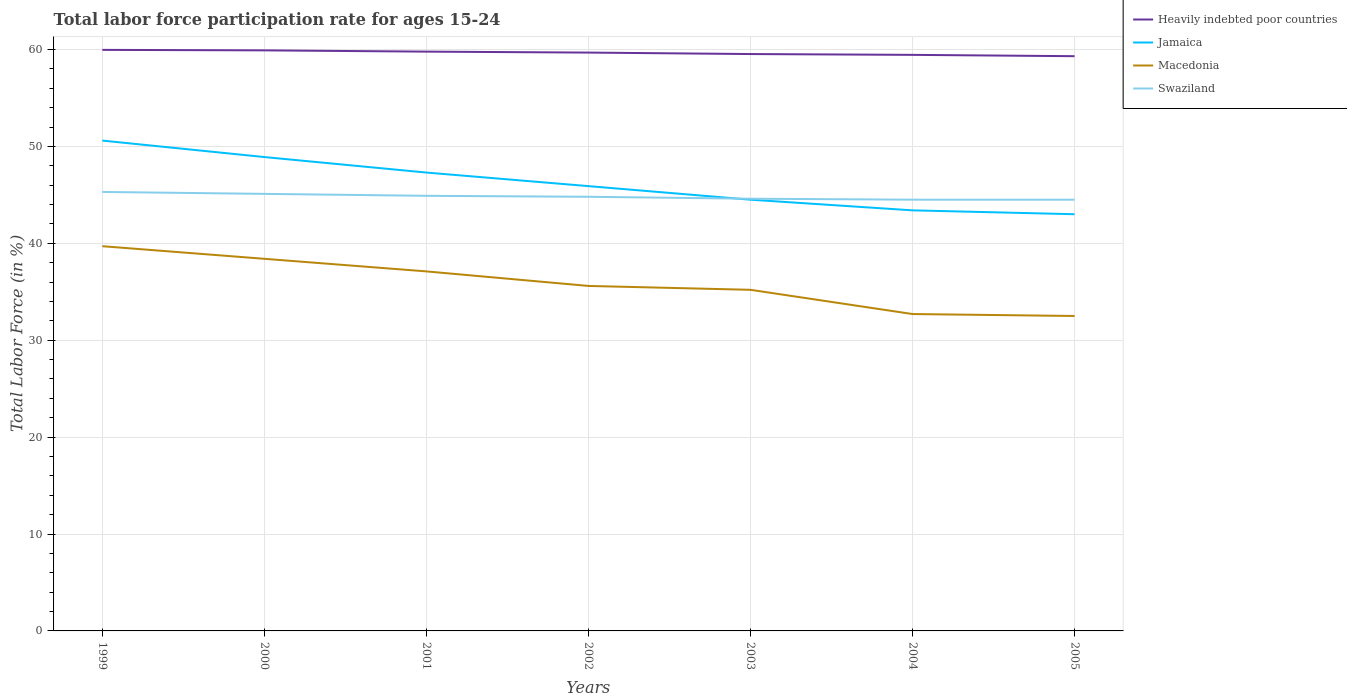How many different coloured lines are there?
Your answer should be compact. 4. Does the line corresponding to Heavily indebted poor countries intersect with the line corresponding to Swaziland?
Offer a terse response. No. Is the number of lines equal to the number of legend labels?
Ensure brevity in your answer.  Yes. Across all years, what is the maximum labor force participation rate in Macedonia?
Your answer should be compact. 32.5. In which year was the labor force participation rate in Heavily indebted poor countries maximum?
Your answer should be compact. 2005. What is the total labor force participation rate in Jamaica in the graph?
Ensure brevity in your answer.  3. What is the difference between the highest and the second highest labor force participation rate in Swaziland?
Your response must be concise. 0.8. What is the difference between the highest and the lowest labor force participation rate in Heavily indebted poor countries?
Provide a succinct answer. 4. Is the labor force participation rate in Macedonia strictly greater than the labor force participation rate in Swaziland over the years?
Offer a terse response. Yes. What is the difference between two consecutive major ticks on the Y-axis?
Your response must be concise. 10. Does the graph contain grids?
Provide a short and direct response. Yes. Where does the legend appear in the graph?
Your answer should be compact. Top right. How are the legend labels stacked?
Your answer should be very brief. Vertical. What is the title of the graph?
Provide a succinct answer. Total labor force participation rate for ages 15-24. What is the Total Labor Force (in %) of Heavily indebted poor countries in 1999?
Provide a succinct answer. 59.96. What is the Total Labor Force (in %) in Jamaica in 1999?
Your answer should be compact. 50.6. What is the Total Labor Force (in %) in Macedonia in 1999?
Make the answer very short. 39.7. What is the Total Labor Force (in %) in Swaziland in 1999?
Your answer should be very brief. 45.3. What is the Total Labor Force (in %) in Heavily indebted poor countries in 2000?
Offer a terse response. 59.91. What is the Total Labor Force (in %) in Jamaica in 2000?
Keep it short and to the point. 48.9. What is the Total Labor Force (in %) of Macedonia in 2000?
Ensure brevity in your answer.  38.4. What is the Total Labor Force (in %) of Swaziland in 2000?
Your answer should be compact. 45.1. What is the Total Labor Force (in %) in Heavily indebted poor countries in 2001?
Ensure brevity in your answer.  59.78. What is the Total Labor Force (in %) of Jamaica in 2001?
Your answer should be compact. 47.3. What is the Total Labor Force (in %) in Macedonia in 2001?
Offer a terse response. 37.1. What is the Total Labor Force (in %) of Swaziland in 2001?
Make the answer very short. 44.9. What is the Total Labor Force (in %) in Heavily indebted poor countries in 2002?
Provide a short and direct response. 59.68. What is the Total Labor Force (in %) of Jamaica in 2002?
Provide a succinct answer. 45.9. What is the Total Labor Force (in %) of Macedonia in 2002?
Offer a very short reply. 35.6. What is the Total Labor Force (in %) of Swaziland in 2002?
Give a very brief answer. 44.8. What is the Total Labor Force (in %) of Heavily indebted poor countries in 2003?
Offer a terse response. 59.53. What is the Total Labor Force (in %) of Jamaica in 2003?
Your answer should be compact. 44.5. What is the Total Labor Force (in %) in Macedonia in 2003?
Your answer should be compact. 35.2. What is the Total Labor Force (in %) of Swaziland in 2003?
Provide a succinct answer. 44.6. What is the Total Labor Force (in %) in Heavily indebted poor countries in 2004?
Provide a short and direct response. 59.45. What is the Total Labor Force (in %) in Jamaica in 2004?
Offer a very short reply. 43.4. What is the Total Labor Force (in %) in Macedonia in 2004?
Ensure brevity in your answer.  32.7. What is the Total Labor Force (in %) of Swaziland in 2004?
Offer a very short reply. 44.5. What is the Total Labor Force (in %) of Heavily indebted poor countries in 2005?
Provide a short and direct response. 59.31. What is the Total Labor Force (in %) in Jamaica in 2005?
Make the answer very short. 43. What is the Total Labor Force (in %) in Macedonia in 2005?
Ensure brevity in your answer.  32.5. What is the Total Labor Force (in %) in Swaziland in 2005?
Your answer should be very brief. 44.5. Across all years, what is the maximum Total Labor Force (in %) of Heavily indebted poor countries?
Your answer should be compact. 59.96. Across all years, what is the maximum Total Labor Force (in %) of Jamaica?
Provide a succinct answer. 50.6. Across all years, what is the maximum Total Labor Force (in %) in Macedonia?
Your answer should be compact. 39.7. Across all years, what is the maximum Total Labor Force (in %) of Swaziland?
Offer a very short reply. 45.3. Across all years, what is the minimum Total Labor Force (in %) in Heavily indebted poor countries?
Provide a short and direct response. 59.31. Across all years, what is the minimum Total Labor Force (in %) of Macedonia?
Your answer should be compact. 32.5. Across all years, what is the minimum Total Labor Force (in %) of Swaziland?
Make the answer very short. 44.5. What is the total Total Labor Force (in %) in Heavily indebted poor countries in the graph?
Provide a short and direct response. 417.61. What is the total Total Labor Force (in %) in Jamaica in the graph?
Give a very brief answer. 323.6. What is the total Total Labor Force (in %) of Macedonia in the graph?
Offer a very short reply. 251.2. What is the total Total Labor Force (in %) of Swaziland in the graph?
Your answer should be very brief. 313.7. What is the difference between the Total Labor Force (in %) of Heavily indebted poor countries in 1999 and that in 2000?
Your response must be concise. 0.05. What is the difference between the Total Labor Force (in %) in Jamaica in 1999 and that in 2000?
Give a very brief answer. 1.7. What is the difference between the Total Labor Force (in %) of Heavily indebted poor countries in 1999 and that in 2001?
Keep it short and to the point. 0.18. What is the difference between the Total Labor Force (in %) of Jamaica in 1999 and that in 2001?
Provide a short and direct response. 3.3. What is the difference between the Total Labor Force (in %) in Macedonia in 1999 and that in 2001?
Your answer should be very brief. 2.6. What is the difference between the Total Labor Force (in %) in Swaziland in 1999 and that in 2001?
Make the answer very short. 0.4. What is the difference between the Total Labor Force (in %) of Heavily indebted poor countries in 1999 and that in 2002?
Keep it short and to the point. 0.28. What is the difference between the Total Labor Force (in %) in Swaziland in 1999 and that in 2002?
Offer a very short reply. 0.5. What is the difference between the Total Labor Force (in %) of Heavily indebted poor countries in 1999 and that in 2003?
Provide a short and direct response. 0.43. What is the difference between the Total Labor Force (in %) of Jamaica in 1999 and that in 2003?
Provide a short and direct response. 6.1. What is the difference between the Total Labor Force (in %) in Heavily indebted poor countries in 1999 and that in 2004?
Provide a short and direct response. 0.51. What is the difference between the Total Labor Force (in %) in Jamaica in 1999 and that in 2004?
Keep it short and to the point. 7.2. What is the difference between the Total Labor Force (in %) of Heavily indebted poor countries in 1999 and that in 2005?
Provide a short and direct response. 0.65. What is the difference between the Total Labor Force (in %) of Macedonia in 1999 and that in 2005?
Give a very brief answer. 7.2. What is the difference between the Total Labor Force (in %) in Swaziland in 1999 and that in 2005?
Keep it short and to the point. 0.8. What is the difference between the Total Labor Force (in %) in Heavily indebted poor countries in 2000 and that in 2001?
Offer a very short reply. 0.13. What is the difference between the Total Labor Force (in %) in Jamaica in 2000 and that in 2001?
Your answer should be very brief. 1.6. What is the difference between the Total Labor Force (in %) in Macedonia in 2000 and that in 2001?
Give a very brief answer. 1.3. What is the difference between the Total Labor Force (in %) in Swaziland in 2000 and that in 2001?
Your response must be concise. 0.2. What is the difference between the Total Labor Force (in %) in Heavily indebted poor countries in 2000 and that in 2002?
Your answer should be very brief. 0.23. What is the difference between the Total Labor Force (in %) of Heavily indebted poor countries in 2000 and that in 2003?
Keep it short and to the point. 0.38. What is the difference between the Total Labor Force (in %) in Jamaica in 2000 and that in 2003?
Your response must be concise. 4.4. What is the difference between the Total Labor Force (in %) in Macedonia in 2000 and that in 2003?
Provide a short and direct response. 3.2. What is the difference between the Total Labor Force (in %) of Heavily indebted poor countries in 2000 and that in 2004?
Your answer should be very brief. 0.46. What is the difference between the Total Labor Force (in %) of Jamaica in 2000 and that in 2004?
Give a very brief answer. 5.5. What is the difference between the Total Labor Force (in %) in Heavily indebted poor countries in 2000 and that in 2005?
Make the answer very short. 0.6. What is the difference between the Total Labor Force (in %) in Jamaica in 2000 and that in 2005?
Ensure brevity in your answer.  5.9. What is the difference between the Total Labor Force (in %) of Macedonia in 2000 and that in 2005?
Your answer should be compact. 5.9. What is the difference between the Total Labor Force (in %) in Swaziland in 2000 and that in 2005?
Ensure brevity in your answer.  0.6. What is the difference between the Total Labor Force (in %) of Heavily indebted poor countries in 2001 and that in 2002?
Keep it short and to the point. 0.1. What is the difference between the Total Labor Force (in %) in Jamaica in 2001 and that in 2002?
Your answer should be compact. 1.4. What is the difference between the Total Labor Force (in %) in Swaziland in 2001 and that in 2002?
Make the answer very short. 0.1. What is the difference between the Total Labor Force (in %) in Heavily indebted poor countries in 2001 and that in 2003?
Ensure brevity in your answer.  0.25. What is the difference between the Total Labor Force (in %) of Macedonia in 2001 and that in 2003?
Provide a short and direct response. 1.9. What is the difference between the Total Labor Force (in %) in Heavily indebted poor countries in 2001 and that in 2004?
Your response must be concise. 0.33. What is the difference between the Total Labor Force (in %) in Jamaica in 2001 and that in 2004?
Give a very brief answer. 3.9. What is the difference between the Total Labor Force (in %) of Heavily indebted poor countries in 2001 and that in 2005?
Ensure brevity in your answer.  0.47. What is the difference between the Total Labor Force (in %) of Swaziland in 2001 and that in 2005?
Your response must be concise. 0.4. What is the difference between the Total Labor Force (in %) in Heavily indebted poor countries in 2002 and that in 2003?
Your answer should be very brief. 0.15. What is the difference between the Total Labor Force (in %) of Macedonia in 2002 and that in 2003?
Your answer should be very brief. 0.4. What is the difference between the Total Labor Force (in %) in Heavily indebted poor countries in 2002 and that in 2004?
Provide a succinct answer. 0.23. What is the difference between the Total Labor Force (in %) of Jamaica in 2002 and that in 2004?
Provide a short and direct response. 2.5. What is the difference between the Total Labor Force (in %) in Macedonia in 2002 and that in 2004?
Make the answer very short. 2.9. What is the difference between the Total Labor Force (in %) in Swaziland in 2002 and that in 2004?
Ensure brevity in your answer.  0.3. What is the difference between the Total Labor Force (in %) of Heavily indebted poor countries in 2002 and that in 2005?
Offer a very short reply. 0.37. What is the difference between the Total Labor Force (in %) in Jamaica in 2002 and that in 2005?
Offer a terse response. 2.9. What is the difference between the Total Labor Force (in %) of Heavily indebted poor countries in 2003 and that in 2004?
Provide a short and direct response. 0.08. What is the difference between the Total Labor Force (in %) in Jamaica in 2003 and that in 2004?
Ensure brevity in your answer.  1.1. What is the difference between the Total Labor Force (in %) of Swaziland in 2003 and that in 2004?
Keep it short and to the point. 0.1. What is the difference between the Total Labor Force (in %) of Heavily indebted poor countries in 2003 and that in 2005?
Ensure brevity in your answer.  0.22. What is the difference between the Total Labor Force (in %) in Jamaica in 2003 and that in 2005?
Your answer should be very brief. 1.5. What is the difference between the Total Labor Force (in %) of Swaziland in 2003 and that in 2005?
Offer a terse response. 0.1. What is the difference between the Total Labor Force (in %) in Heavily indebted poor countries in 2004 and that in 2005?
Your answer should be compact. 0.14. What is the difference between the Total Labor Force (in %) in Heavily indebted poor countries in 1999 and the Total Labor Force (in %) in Jamaica in 2000?
Your response must be concise. 11.06. What is the difference between the Total Labor Force (in %) in Heavily indebted poor countries in 1999 and the Total Labor Force (in %) in Macedonia in 2000?
Offer a very short reply. 21.56. What is the difference between the Total Labor Force (in %) in Heavily indebted poor countries in 1999 and the Total Labor Force (in %) in Swaziland in 2000?
Make the answer very short. 14.86. What is the difference between the Total Labor Force (in %) in Macedonia in 1999 and the Total Labor Force (in %) in Swaziland in 2000?
Provide a short and direct response. -5.4. What is the difference between the Total Labor Force (in %) in Heavily indebted poor countries in 1999 and the Total Labor Force (in %) in Jamaica in 2001?
Offer a very short reply. 12.66. What is the difference between the Total Labor Force (in %) of Heavily indebted poor countries in 1999 and the Total Labor Force (in %) of Macedonia in 2001?
Give a very brief answer. 22.86. What is the difference between the Total Labor Force (in %) of Heavily indebted poor countries in 1999 and the Total Labor Force (in %) of Swaziland in 2001?
Offer a very short reply. 15.06. What is the difference between the Total Labor Force (in %) in Jamaica in 1999 and the Total Labor Force (in %) in Macedonia in 2001?
Provide a succinct answer. 13.5. What is the difference between the Total Labor Force (in %) of Macedonia in 1999 and the Total Labor Force (in %) of Swaziland in 2001?
Provide a short and direct response. -5.2. What is the difference between the Total Labor Force (in %) in Heavily indebted poor countries in 1999 and the Total Labor Force (in %) in Jamaica in 2002?
Ensure brevity in your answer.  14.06. What is the difference between the Total Labor Force (in %) in Heavily indebted poor countries in 1999 and the Total Labor Force (in %) in Macedonia in 2002?
Keep it short and to the point. 24.36. What is the difference between the Total Labor Force (in %) in Heavily indebted poor countries in 1999 and the Total Labor Force (in %) in Swaziland in 2002?
Your answer should be compact. 15.16. What is the difference between the Total Labor Force (in %) of Jamaica in 1999 and the Total Labor Force (in %) of Macedonia in 2002?
Your answer should be compact. 15. What is the difference between the Total Labor Force (in %) of Jamaica in 1999 and the Total Labor Force (in %) of Swaziland in 2002?
Provide a short and direct response. 5.8. What is the difference between the Total Labor Force (in %) of Macedonia in 1999 and the Total Labor Force (in %) of Swaziland in 2002?
Keep it short and to the point. -5.1. What is the difference between the Total Labor Force (in %) in Heavily indebted poor countries in 1999 and the Total Labor Force (in %) in Jamaica in 2003?
Offer a very short reply. 15.46. What is the difference between the Total Labor Force (in %) of Heavily indebted poor countries in 1999 and the Total Labor Force (in %) of Macedonia in 2003?
Offer a very short reply. 24.76. What is the difference between the Total Labor Force (in %) of Heavily indebted poor countries in 1999 and the Total Labor Force (in %) of Swaziland in 2003?
Give a very brief answer. 15.36. What is the difference between the Total Labor Force (in %) of Jamaica in 1999 and the Total Labor Force (in %) of Macedonia in 2003?
Your answer should be very brief. 15.4. What is the difference between the Total Labor Force (in %) in Macedonia in 1999 and the Total Labor Force (in %) in Swaziland in 2003?
Your answer should be very brief. -4.9. What is the difference between the Total Labor Force (in %) in Heavily indebted poor countries in 1999 and the Total Labor Force (in %) in Jamaica in 2004?
Keep it short and to the point. 16.56. What is the difference between the Total Labor Force (in %) of Heavily indebted poor countries in 1999 and the Total Labor Force (in %) of Macedonia in 2004?
Your answer should be compact. 27.26. What is the difference between the Total Labor Force (in %) in Heavily indebted poor countries in 1999 and the Total Labor Force (in %) in Swaziland in 2004?
Offer a very short reply. 15.46. What is the difference between the Total Labor Force (in %) of Jamaica in 1999 and the Total Labor Force (in %) of Macedonia in 2004?
Offer a very short reply. 17.9. What is the difference between the Total Labor Force (in %) in Macedonia in 1999 and the Total Labor Force (in %) in Swaziland in 2004?
Your answer should be compact. -4.8. What is the difference between the Total Labor Force (in %) of Heavily indebted poor countries in 1999 and the Total Labor Force (in %) of Jamaica in 2005?
Keep it short and to the point. 16.96. What is the difference between the Total Labor Force (in %) of Heavily indebted poor countries in 1999 and the Total Labor Force (in %) of Macedonia in 2005?
Make the answer very short. 27.46. What is the difference between the Total Labor Force (in %) in Heavily indebted poor countries in 1999 and the Total Labor Force (in %) in Swaziland in 2005?
Keep it short and to the point. 15.46. What is the difference between the Total Labor Force (in %) of Jamaica in 1999 and the Total Labor Force (in %) of Macedonia in 2005?
Ensure brevity in your answer.  18.1. What is the difference between the Total Labor Force (in %) in Jamaica in 1999 and the Total Labor Force (in %) in Swaziland in 2005?
Keep it short and to the point. 6.1. What is the difference between the Total Labor Force (in %) in Heavily indebted poor countries in 2000 and the Total Labor Force (in %) in Jamaica in 2001?
Your answer should be compact. 12.61. What is the difference between the Total Labor Force (in %) in Heavily indebted poor countries in 2000 and the Total Labor Force (in %) in Macedonia in 2001?
Provide a short and direct response. 22.81. What is the difference between the Total Labor Force (in %) in Heavily indebted poor countries in 2000 and the Total Labor Force (in %) in Swaziland in 2001?
Give a very brief answer. 15.01. What is the difference between the Total Labor Force (in %) in Jamaica in 2000 and the Total Labor Force (in %) in Macedonia in 2001?
Provide a short and direct response. 11.8. What is the difference between the Total Labor Force (in %) of Macedonia in 2000 and the Total Labor Force (in %) of Swaziland in 2001?
Ensure brevity in your answer.  -6.5. What is the difference between the Total Labor Force (in %) of Heavily indebted poor countries in 2000 and the Total Labor Force (in %) of Jamaica in 2002?
Provide a short and direct response. 14.01. What is the difference between the Total Labor Force (in %) of Heavily indebted poor countries in 2000 and the Total Labor Force (in %) of Macedonia in 2002?
Offer a very short reply. 24.31. What is the difference between the Total Labor Force (in %) of Heavily indebted poor countries in 2000 and the Total Labor Force (in %) of Swaziland in 2002?
Your answer should be compact. 15.11. What is the difference between the Total Labor Force (in %) of Jamaica in 2000 and the Total Labor Force (in %) of Swaziland in 2002?
Offer a terse response. 4.1. What is the difference between the Total Labor Force (in %) in Macedonia in 2000 and the Total Labor Force (in %) in Swaziland in 2002?
Ensure brevity in your answer.  -6.4. What is the difference between the Total Labor Force (in %) of Heavily indebted poor countries in 2000 and the Total Labor Force (in %) of Jamaica in 2003?
Your answer should be very brief. 15.41. What is the difference between the Total Labor Force (in %) in Heavily indebted poor countries in 2000 and the Total Labor Force (in %) in Macedonia in 2003?
Make the answer very short. 24.71. What is the difference between the Total Labor Force (in %) in Heavily indebted poor countries in 2000 and the Total Labor Force (in %) in Swaziland in 2003?
Your answer should be compact. 15.31. What is the difference between the Total Labor Force (in %) in Jamaica in 2000 and the Total Labor Force (in %) in Swaziland in 2003?
Ensure brevity in your answer.  4.3. What is the difference between the Total Labor Force (in %) of Macedonia in 2000 and the Total Labor Force (in %) of Swaziland in 2003?
Your answer should be very brief. -6.2. What is the difference between the Total Labor Force (in %) of Heavily indebted poor countries in 2000 and the Total Labor Force (in %) of Jamaica in 2004?
Make the answer very short. 16.51. What is the difference between the Total Labor Force (in %) in Heavily indebted poor countries in 2000 and the Total Labor Force (in %) in Macedonia in 2004?
Give a very brief answer. 27.21. What is the difference between the Total Labor Force (in %) in Heavily indebted poor countries in 2000 and the Total Labor Force (in %) in Swaziland in 2004?
Offer a terse response. 15.41. What is the difference between the Total Labor Force (in %) in Jamaica in 2000 and the Total Labor Force (in %) in Swaziland in 2004?
Ensure brevity in your answer.  4.4. What is the difference between the Total Labor Force (in %) in Macedonia in 2000 and the Total Labor Force (in %) in Swaziland in 2004?
Keep it short and to the point. -6.1. What is the difference between the Total Labor Force (in %) of Heavily indebted poor countries in 2000 and the Total Labor Force (in %) of Jamaica in 2005?
Offer a very short reply. 16.91. What is the difference between the Total Labor Force (in %) in Heavily indebted poor countries in 2000 and the Total Labor Force (in %) in Macedonia in 2005?
Your answer should be compact. 27.41. What is the difference between the Total Labor Force (in %) of Heavily indebted poor countries in 2000 and the Total Labor Force (in %) of Swaziland in 2005?
Provide a succinct answer. 15.41. What is the difference between the Total Labor Force (in %) of Jamaica in 2000 and the Total Labor Force (in %) of Swaziland in 2005?
Make the answer very short. 4.4. What is the difference between the Total Labor Force (in %) of Heavily indebted poor countries in 2001 and the Total Labor Force (in %) of Jamaica in 2002?
Give a very brief answer. 13.88. What is the difference between the Total Labor Force (in %) in Heavily indebted poor countries in 2001 and the Total Labor Force (in %) in Macedonia in 2002?
Give a very brief answer. 24.18. What is the difference between the Total Labor Force (in %) of Heavily indebted poor countries in 2001 and the Total Labor Force (in %) of Swaziland in 2002?
Provide a succinct answer. 14.98. What is the difference between the Total Labor Force (in %) in Jamaica in 2001 and the Total Labor Force (in %) in Macedonia in 2002?
Your answer should be very brief. 11.7. What is the difference between the Total Labor Force (in %) in Macedonia in 2001 and the Total Labor Force (in %) in Swaziland in 2002?
Offer a terse response. -7.7. What is the difference between the Total Labor Force (in %) of Heavily indebted poor countries in 2001 and the Total Labor Force (in %) of Jamaica in 2003?
Provide a short and direct response. 15.28. What is the difference between the Total Labor Force (in %) of Heavily indebted poor countries in 2001 and the Total Labor Force (in %) of Macedonia in 2003?
Ensure brevity in your answer.  24.58. What is the difference between the Total Labor Force (in %) of Heavily indebted poor countries in 2001 and the Total Labor Force (in %) of Swaziland in 2003?
Ensure brevity in your answer.  15.18. What is the difference between the Total Labor Force (in %) in Heavily indebted poor countries in 2001 and the Total Labor Force (in %) in Jamaica in 2004?
Offer a terse response. 16.38. What is the difference between the Total Labor Force (in %) in Heavily indebted poor countries in 2001 and the Total Labor Force (in %) in Macedonia in 2004?
Make the answer very short. 27.08. What is the difference between the Total Labor Force (in %) in Heavily indebted poor countries in 2001 and the Total Labor Force (in %) in Swaziland in 2004?
Your answer should be very brief. 15.28. What is the difference between the Total Labor Force (in %) of Jamaica in 2001 and the Total Labor Force (in %) of Swaziland in 2004?
Your answer should be very brief. 2.8. What is the difference between the Total Labor Force (in %) of Macedonia in 2001 and the Total Labor Force (in %) of Swaziland in 2004?
Offer a very short reply. -7.4. What is the difference between the Total Labor Force (in %) of Heavily indebted poor countries in 2001 and the Total Labor Force (in %) of Jamaica in 2005?
Ensure brevity in your answer.  16.78. What is the difference between the Total Labor Force (in %) in Heavily indebted poor countries in 2001 and the Total Labor Force (in %) in Macedonia in 2005?
Keep it short and to the point. 27.28. What is the difference between the Total Labor Force (in %) in Heavily indebted poor countries in 2001 and the Total Labor Force (in %) in Swaziland in 2005?
Make the answer very short. 15.28. What is the difference between the Total Labor Force (in %) in Macedonia in 2001 and the Total Labor Force (in %) in Swaziland in 2005?
Make the answer very short. -7.4. What is the difference between the Total Labor Force (in %) in Heavily indebted poor countries in 2002 and the Total Labor Force (in %) in Jamaica in 2003?
Your answer should be compact. 15.18. What is the difference between the Total Labor Force (in %) of Heavily indebted poor countries in 2002 and the Total Labor Force (in %) of Macedonia in 2003?
Offer a very short reply. 24.48. What is the difference between the Total Labor Force (in %) in Heavily indebted poor countries in 2002 and the Total Labor Force (in %) in Swaziland in 2003?
Ensure brevity in your answer.  15.08. What is the difference between the Total Labor Force (in %) of Heavily indebted poor countries in 2002 and the Total Labor Force (in %) of Jamaica in 2004?
Offer a very short reply. 16.28. What is the difference between the Total Labor Force (in %) in Heavily indebted poor countries in 2002 and the Total Labor Force (in %) in Macedonia in 2004?
Your answer should be compact. 26.98. What is the difference between the Total Labor Force (in %) of Heavily indebted poor countries in 2002 and the Total Labor Force (in %) of Swaziland in 2004?
Your answer should be very brief. 15.18. What is the difference between the Total Labor Force (in %) of Jamaica in 2002 and the Total Labor Force (in %) of Swaziland in 2004?
Your answer should be compact. 1.4. What is the difference between the Total Labor Force (in %) in Macedonia in 2002 and the Total Labor Force (in %) in Swaziland in 2004?
Give a very brief answer. -8.9. What is the difference between the Total Labor Force (in %) of Heavily indebted poor countries in 2002 and the Total Labor Force (in %) of Jamaica in 2005?
Give a very brief answer. 16.68. What is the difference between the Total Labor Force (in %) of Heavily indebted poor countries in 2002 and the Total Labor Force (in %) of Macedonia in 2005?
Keep it short and to the point. 27.18. What is the difference between the Total Labor Force (in %) in Heavily indebted poor countries in 2002 and the Total Labor Force (in %) in Swaziland in 2005?
Make the answer very short. 15.18. What is the difference between the Total Labor Force (in %) of Jamaica in 2002 and the Total Labor Force (in %) of Macedonia in 2005?
Ensure brevity in your answer.  13.4. What is the difference between the Total Labor Force (in %) in Jamaica in 2002 and the Total Labor Force (in %) in Swaziland in 2005?
Your response must be concise. 1.4. What is the difference between the Total Labor Force (in %) of Heavily indebted poor countries in 2003 and the Total Labor Force (in %) of Jamaica in 2004?
Give a very brief answer. 16.13. What is the difference between the Total Labor Force (in %) in Heavily indebted poor countries in 2003 and the Total Labor Force (in %) in Macedonia in 2004?
Provide a succinct answer. 26.83. What is the difference between the Total Labor Force (in %) in Heavily indebted poor countries in 2003 and the Total Labor Force (in %) in Swaziland in 2004?
Offer a very short reply. 15.03. What is the difference between the Total Labor Force (in %) of Jamaica in 2003 and the Total Labor Force (in %) of Macedonia in 2004?
Your answer should be very brief. 11.8. What is the difference between the Total Labor Force (in %) of Heavily indebted poor countries in 2003 and the Total Labor Force (in %) of Jamaica in 2005?
Provide a short and direct response. 16.53. What is the difference between the Total Labor Force (in %) of Heavily indebted poor countries in 2003 and the Total Labor Force (in %) of Macedonia in 2005?
Provide a short and direct response. 27.03. What is the difference between the Total Labor Force (in %) in Heavily indebted poor countries in 2003 and the Total Labor Force (in %) in Swaziland in 2005?
Your response must be concise. 15.03. What is the difference between the Total Labor Force (in %) in Jamaica in 2003 and the Total Labor Force (in %) in Macedonia in 2005?
Provide a succinct answer. 12. What is the difference between the Total Labor Force (in %) of Jamaica in 2003 and the Total Labor Force (in %) of Swaziland in 2005?
Give a very brief answer. 0. What is the difference between the Total Labor Force (in %) in Heavily indebted poor countries in 2004 and the Total Labor Force (in %) in Jamaica in 2005?
Keep it short and to the point. 16.45. What is the difference between the Total Labor Force (in %) of Heavily indebted poor countries in 2004 and the Total Labor Force (in %) of Macedonia in 2005?
Keep it short and to the point. 26.95. What is the difference between the Total Labor Force (in %) of Heavily indebted poor countries in 2004 and the Total Labor Force (in %) of Swaziland in 2005?
Provide a short and direct response. 14.95. What is the difference between the Total Labor Force (in %) of Jamaica in 2004 and the Total Labor Force (in %) of Swaziland in 2005?
Your response must be concise. -1.1. What is the difference between the Total Labor Force (in %) of Macedonia in 2004 and the Total Labor Force (in %) of Swaziland in 2005?
Keep it short and to the point. -11.8. What is the average Total Labor Force (in %) of Heavily indebted poor countries per year?
Offer a very short reply. 59.66. What is the average Total Labor Force (in %) of Jamaica per year?
Keep it short and to the point. 46.23. What is the average Total Labor Force (in %) of Macedonia per year?
Keep it short and to the point. 35.89. What is the average Total Labor Force (in %) of Swaziland per year?
Provide a succinct answer. 44.81. In the year 1999, what is the difference between the Total Labor Force (in %) in Heavily indebted poor countries and Total Labor Force (in %) in Jamaica?
Give a very brief answer. 9.36. In the year 1999, what is the difference between the Total Labor Force (in %) of Heavily indebted poor countries and Total Labor Force (in %) of Macedonia?
Keep it short and to the point. 20.26. In the year 1999, what is the difference between the Total Labor Force (in %) in Heavily indebted poor countries and Total Labor Force (in %) in Swaziland?
Offer a terse response. 14.66. In the year 1999, what is the difference between the Total Labor Force (in %) in Jamaica and Total Labor Force (in %) in Macedonia?
Keep it short and to the point. 10.9. In the year 2000, what is the difference between the Total Labor Force (in %) of Heavily indebted poor countries and Total Labor Force (in %) of Jamaica?
Give a very brief answer. 11.01. In the year 2000, what is the difference between the Total Labor Force (in %) in Heavily indebted poor countries and Total Labor Force (in %) in Macedonia?
Keep it short and to the point. 21.51. In the year 2000, what is the difference between the Total Labor Force (in %) in Heavily indebted poor countries and Total Labor Force (in %) in Swaziland?
Offer a very short reply. 14.81. In the year 2000, what is the difference between the Total Labor Force (in %) of Jamaica and Total Labor Force (in %) of Macedonia?
Your response must be concise. 10.5. In the year 2000, what is the difference between the Total Labor Force (in %) of Macedonia and Total Labor Force (in %) of Swaziland?
Ensure brevity in your answer.  -6.7. In the year 2001, what is the difference between the Total Labor Force (in %) of Heavily indebted poor countries and Total Labor Force (in %) of Jamaica?
Your answer should be compact. 12.48. In the year 2001, what is the difference between the Total Labor Force (in %) in Heavily indebted poor countries and Total Labor Force (in %) in Macedonia?
Offer a terse response. 22.68. In the year 2001, what is the difference between the Total Labor Force (in %) in Heavily indebted poor countries and Total Labor Force (in %) in Swaziland?
Give a very brief answer. 14.88. In the year 2001, what is the difference between the Total Labor Force (in %) in Jamaica and Total Labor Force (in %) in Swaziland?
Your answer should be compact. 2.4. In the year 2001, what is the difference between the Total Labor Force (in %) of Macedonia and Total Labor Force (in %) of Swaziland?
Offer a very short reply. -7.8. In the year 2002, what is the difference between the Total Labor Force (in %) of Heavily indebted poor countries and Total Labor Force (in %) of Jamaica?
Provide a succinct answer. 13.78. In the year 2002, what is the difference between the Total Labor Force (in %) in Heavily indebted poor countries and Total Labor Force (in %) in Macedonia?
Your response must be concise. 24.08. In the year 2002, what is the difference between the Total Labor Force (in %) of Heavily indebted poor countries and Total Labor Force (in %) of Swaziland?
Offer a very short reply. 14.88. In the year 2002, what is the difference between the Total Labor Force (in %) in Jamaica and Total Labor Force (in %) in Macedonia?
Your answer should be very brief. 10.3. In the year 2002, what is the difference between the Total Labor Force (in %) in Jamaica and Total Labor Force (in %) in Swaziland?
Your response must be concise. 1.1. In the year 2002, what is the difference between the Total Labor Force (in %) in Macedonia and Total Labor Force (in %) in Swaziland?
Provide a succinct answer. -9.2. In the year 2003, what is the difference between the Total Labor Force (in %) of Heavily indebted poor countries and Total Labor Force (in %) of Jamaica?
Your answer should be very brief. 15.03. In the year 2003, what is the difference between the Total Labor Force (in %) in Heavily indebted poor countries and Total Labor Force (in %) in Macedonia?
Make the answer very short. 24.33. In the year 2003, what is the difference between the Total Labor Force (in %) of Heavily indebted poor countries and Total Labor Force (in %) of Swaziland?
Provide a succinct answer. 14.93. In the year 2003, what is the difference between the Total Labor Force (in %) in Jamaica and Total Labor Force (in %) in Swaziland?
Offer a very short reply. -0.1. In the year 2003, what is the difference between the Total Labor Force (in %) of Macedonia and Total Labor Force (in %) of Swaziland?
Keep it short and to the point. -9.4. In the year 2004, what is the difference between the Total Labor Force (in %) in Heavily indebted poor countries and Total Labor Force (in %) in Jamaica?
Keep it short and to the point. 16.05. In the year 2004, what is the difference between the Total Labor Force (in %) in Heavily indebted poor countries and Total Labor Force (in %) in Macedonia?
Your answer should be very brief. 26.75. In the year 2004, what is the difference between the Total Labor Force (in %) of Heavily indebted poor countries and Total Labor Force (in %) of Swaziland?
Provide a succinct answer. 14.95. In the year 2004, what is the difference between the Total Labor Force (in %) in Jamaica and Total Labor Force (in %) in Macedonia?
Ensure brevity in your answer.  10.7. In the year 2005, what is the difference between the Total Labor Force (in %) in Heavily indebted poor countries and Total Labor Force (in %) in Jamaica?
Make the answer very short. 16.31. In the year 2005, what is the difference between the Total Labor Force (in %) of Heavily indebted poor countries and Total Labor Force (in %) of Macedonia?
Your answer should be very brief. 26.81. In the year 2005, what is the difference between the Total Labor Force (in %) in Heavily indebted poor countries and Total Labor Force (in %) in Swaziland?
Provide a succinct answer. 14.81. What is the ratio of the Total Labor Force (in %) in Jamaica in 1999 to that in 2000?
Your answer should be very brief. 1.03. What is the ratio of the Total Labor Force (in %) of Macedonia in 1999 to that in 2000?
Offer a terse response. 1.03. What is the ratio of the Total Labor Force (in %) in Swaziland in 1999 to that in 2000?
Offer a terse response. 1. What is the ratio of the Total Labor Force (in %) in Jamaica in 1999 to that in 2001?
Offer a terse response. 1.07. What is the ratio of the Total Labor Force (in %) of Macedonia in 1999 to that in 2001?
Provide a succinct answer. 1.07. What is the ratio of the Total Labor Force (in %) of Swaziland in 1999 to that in 2001?
Ensure brevity in your answer.  1.01. What is the ratio of the Total Labor Force (in %) in Jamaica in 1999 to that in 2002?
Your response must be concise. 1.1. What is the ratio of the Total Labor Force (in %) in Macedonia in 1999 to that in 2002?
Provide a short and direct response. 1.12. What is the ratio of the Total Labor Force (in %) of Swaziland in 1999 to that in 2002?
Ensure brevity in your answer.  1.01. What is the ratio of the Total Labor Force (in %) in Jamaica in 1999 to that in 2003?
Give a very brief answer. 1.14. What is the ratio of the Total Labor Force (in %) in Macedonia in 1999 to that in 2003?
Offer a very short reply. 1.13. What is the ratio of the Total Labor Force (in %) of Swaziland in 1999 to that in 2003?
Make the answer very short. 1.02. What is the ratio of the Total Labor Force (in %) in Heavily indebted poor countries in 1999 to that in 2004?
Provide a succinct answer. 1.01. What is the ratio of the Total Labor Force (in %) in Jamaica in 1999 to that in 2004?
Provide a succinct answer. 1.17. What is the ratio of the Total Labor Force (in %) in Macedonia in 1999 to that in 2004?
Your answer should be compact. 1.21. What is the ratio of the Total Labor Force (in %) of Jamaica in 1999 to that in 2005?
Offer a terse response. 1.18. What is the ratio of the Total Labor Force (in %) of Macedonia in 1999 to that in 2005?
Offer a terse response. 1.22. What is the ratio of the Total Labor Force (in %) of Swaziland in 1999 to that in 2005?
Offer a terse response. 1.02. What is the ratio of the Total Labor Force (in %) of Heavily indebted poor countries in 2000 to that in 2001?
Give a very brief answer. 1. What is the ratio of the Total Labor Force (in %) in Jamaica in 2000 to that in 2001?
Offer a terse response. 1.03. What is the ratio of the Total Labor Force (in %) of Macedonia in 2000 to that in 2001?
Your answer should be very brief. 1.03. What is the ratio of the Total Labor Force (in %) of Jamaica in 2000 to that in 2002?
Ensure brevity in your answer.  1.07. What is the ratio of the Total Labor Force (in %) in Macedonia in 2000 to that in 2002?
Provide a short and direct response. 1.08. What is the ratio of the Total Labor Force (in %) in Heavily indebted poor countries in 2000 to that in 2003?
Offer a very short reply. 1.01. What is the ratio of the Total Labor Force (in %) in Jamaica in 2000 to that in 2003?
Offer a terse response. 1.1. What is the ratio of the Total Labor Force (in %) of Macedonia in 2000 to that in 2003?
Ensure brevity in your answer.  1.09. What is the ratio of the Total Labor Force (in %) of Swaziland in 2000 to that in 2003?
Your response must be concise. 1.01. What is the ratio of the Total Labor Force (in %) in Heavily indebted poor countries in 2000 to that in 2004?
Keep it short and to the point. 1.01. What is the ratio of the Total Labor Force (in %) in Jamaica in 2000 to that in 2004?
Offer a terse response. 1.13. What is the ratio of the Total Labor Force (in %) in Macedonia in 2000 to that in 2004?
Offer a very short reply. 1.17. What is the ratio of the Total Labor Force (in %) of Swaziland in 2000 to that in 2004?
Ensure brevity in your answer.  1.01. What is the ratio of the Total Labor Force (in %) in Jamaica in 2000 to that in 2005?
Give a very brief answer. 1.14. What is the ratio of the Total Labor Force (in %) of Macedonia in 2000 to that in 2005?
Keep it short and to the point. 1.18. What is the ratio of the Total Labor Force (in %) of Swaziland in 2000 to that in 2005?
Keep it short and to the point. 1.01. What is the ratio of the Total Labor Force (in %) of Heavily indebted poor countries in 2001 to that in 2002?
Provide a short and direct response. 1. What is the ratio of the Total Labor Force (in %) in Jamaica in 2001 to that in 2002?
Make the answer very short. 1.03. What is the ratio of the Total Labor Force (in %) in Macedonia in 2001 to that in 2002?
Your answer should be compact. 1.04. What is the ratio of the Total Labor Force (in %) in Jamaica in 2001 to that in 2003?
Provide a short and direct response. 1.06. What is the ratio of the Total Labor Force (in %) in Macedonia in 2001 to that in 2003?
Give a very brief answer. 1.05. What is the ratio of the Total Labor Force (in %) of Heavily indebted poor countries in 2001 to that in 2004?
Give a very brief answer. 1.01. What is the ratio of the Total Labor Force (in %) of Jamaica in 2001 to that in 2004?
Your answer should be very brief. 1.09. What is the ratio of the Total Labor Force (in %) of Macedonia in 2001 to that in 2004?
Offer a terse response. 1.13. What is the ratio of the Total Labor Force (in %) of Heavily indebted poor countries in 2001 to that in 2005?
Give a very brief answer. 1.01. What is the ratio of the Total Labor Force (in %) of Macedonia in 2001 to that in 2005?
Your answer should be compact. 1.14. What is the ratio of the Total Labor Force (in %) in Swaziland in 2001 to that in 2005?
Ensure brevity in your answer.  1.01. What is the ratio of the Total Labor Force (in %) of Heavily indebted poor countries in 2002 to that in 2003?
Make the answer very short. 1. What is the ratio of the Total Labor Force (in %) of Jamaica in 2002 to that in 2003?
Provide a short and direct response. 1.03. What is the ratio of the Total Labor Force (in %) of Macedonia in 2002 to that in 2003?
Make the answer very short. 1.01. What is the ratio of the Total Labor Force (in %) of Jamaica in 2002 to that in 2004?
Offer a very short reply. 1.06. What is the ratio of the Total Labor Force (in %) of Macedonia in 2002 to that in 2004?
Provide a short and direct response. 1.09. What is the ratio of the Total Labor Force (in %) in Jamaica in 2002 to that in 2005?
Give a very brief answer. 1.07. What is the ratio of the Total Labor Force (in %) in Macedonia in 2002 to that in 2005?
Keep it short and to the point. 1.1. What is the ratio of the Total Labor Force (in %) of Heavily indebted poor countries in 2003 to that in 2004?
Ensure brevity in your answer.  1. What is the ratio of the Total Labor Force (in %) in Jamaica in 2003 to that in 2004?
Offer a very short reply. 1.03. What is the ratio of the Total Labor Force (in %) in Macedonia in 2003 to that in 2004?
Offer a very short reply. 1.08. What is the ratio of the Total Labor Force (in %) of Swaziland in 2003 to that in 2004?
Give a very brief answer. 1. What is the ratio of the Total Labor Force (in %) in Heavily indebted poor countries in 2003 to that in 2005?
Offer a very short reply. 1. What is the ratio of the Total Labor Force (in %) in Jamaica in 2003 to that in 2005?
Ensure brevity in your answer.  1.03. What is the ratio of the Total Labor Force (in %) in Macedonia in 2003 to that in 2005?
Make the answer very short. 1.08. What is the ratio of the Total Labor Force (in %) of Swaziland in 2003 to that in 2005?
Keep it short and to the point. 1. What is the ratio of the Total Labor Force (in %) in Heavily indebted poor countries in 2004 to that in 2005?
Your answer should be very brief. 1. What is the ratio of the Total Labor Force (in %) in Jamaica in 2004 to that in 2005?
Your answer should be very brief. 1.01. What is the difference between the highest and the second highest Total Labor Force (in %) of Heavily indebted poor countries?
Ensure brevity in your answer.  0.05. What is the difference between the highest and the second highest Total Labor Force (in %) of Jamaica?
Your response must be concise. 1.7. What is the difference between the highest and the lowest Total Labor Force (in %) of Heavily indebted poor countries?
Your response must be concise. 0.65. What is the difference between the highest and the lowest Total Labor Force (in %) of Jamaica?
Give a very brief answer. 7.6. What is the difference between the highest and the lowest Total Labor Force (in %) of Macedonia?
Provide a short and direct response. 7.2. 